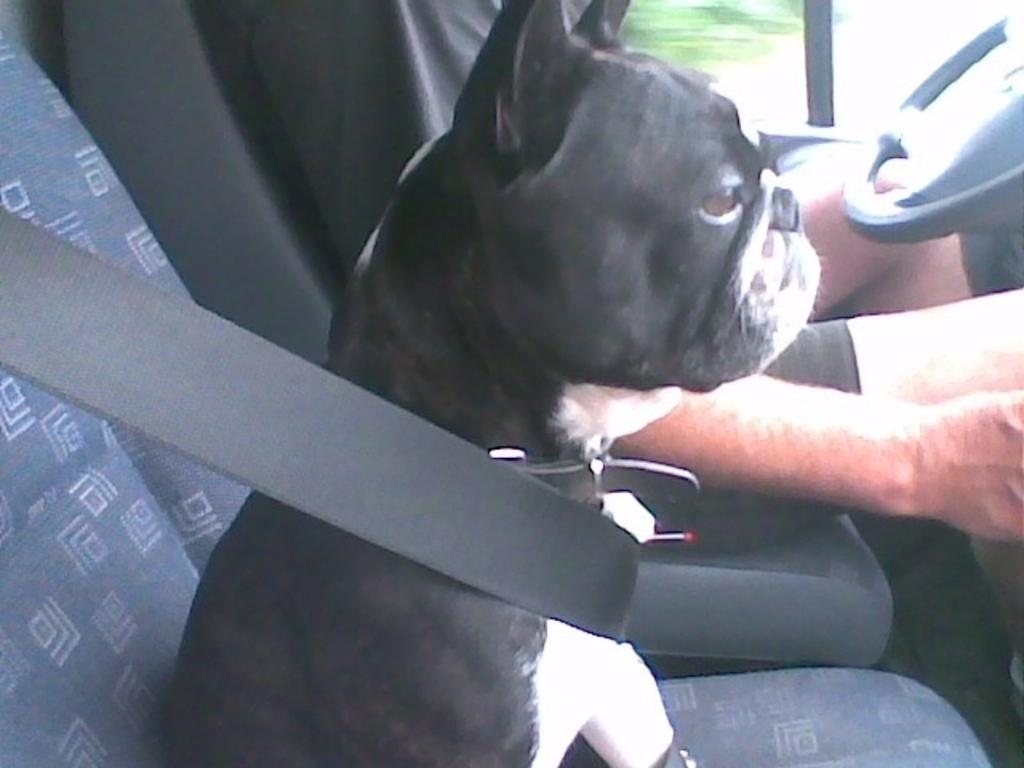What is the main subject in the center of the image? There is a car in the center of the image. Who or what is inside the car? There is a person sitting in the car. What is used to control the direction of the car? There is a steering wheel in the car. What safety feature is present in the car? There is a seat belt in the car. What type of animal is also present in the car? There is a dog in the car. What color is the dog in the car? The dog is black and white in color. What type of credit card is the person using to pay for the car in the image? There is no indication in the image that the person is using a credit card or paying for the car. 